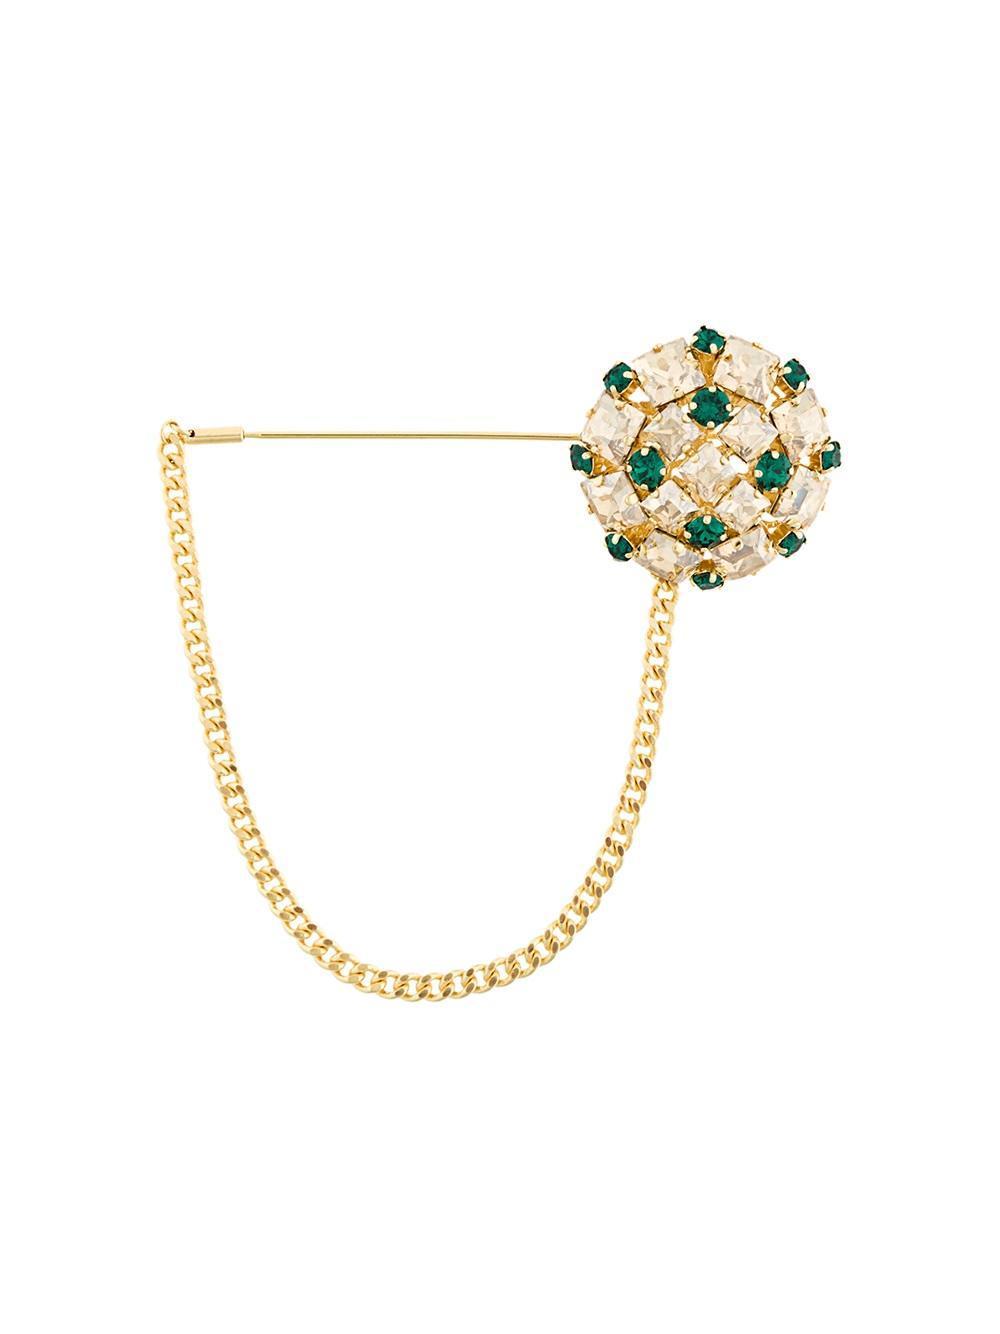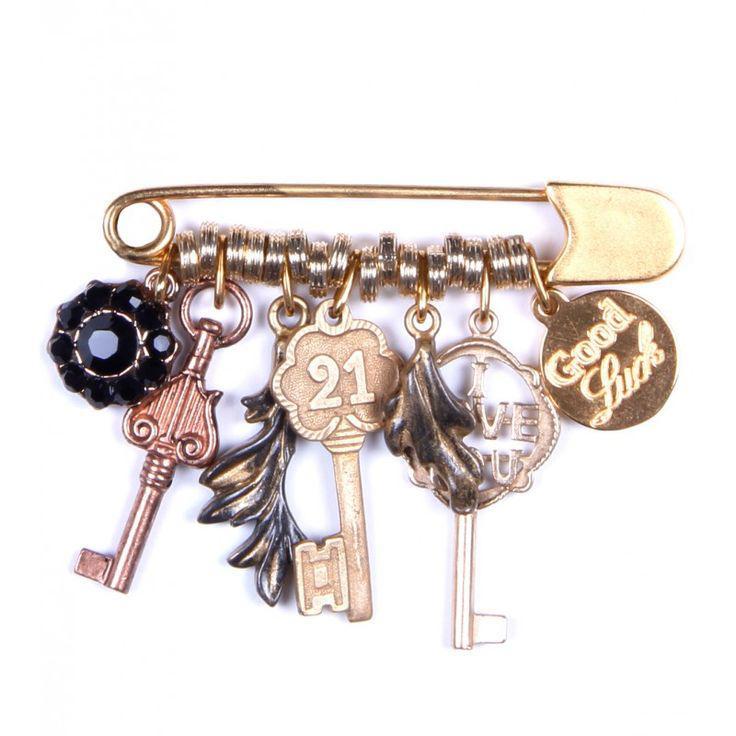The first image is the image on the left, the second image is the image on the right. Assess this claim about the two images: "there is a pin with at least one charm being a key". Correct or not? Answer yes or no. Yes. The first image is the image on the left, the second image is the image on the right. Analyze the images presented: Is the assertion "The pin on the left is strung with six beads, and the pin on the right features gold letter shapes." valid? Answer yes or no. No. 